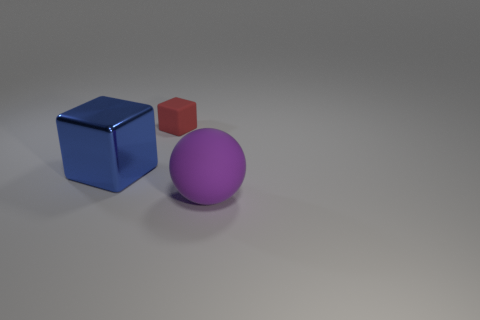Add 3 metallic things. How many objects exist? 6 Subtract all blocks. How many objects are left? 1 Add 3 red things. How many red things are left? 4 Add 3 big purple rubber cubes. How many big purple rubber cubes exist? 3 Subtract 0 brown balls. How many objects are left? 3 Subtract all tiny cubes. Subtract all small yellow metal balls. How many objects are left? 2 